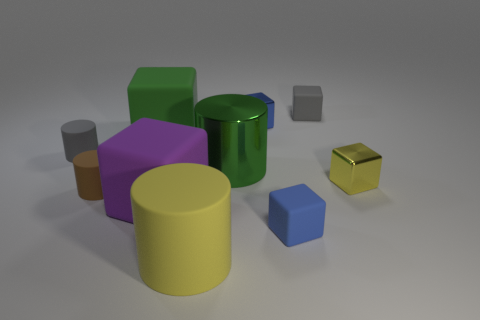Is the number of small gray rubber cylinders that are right of the brown matte cylinder less than the number of rubber blocks that are to the left of the gray matte block?
Ensure brevity in your answer.  Yes. How many large objects are either cylinders or green metal objects?
Give a very brief answer. 2. There is a small gray object to the left of the big yellow rubber cylinder; does it have the same shape as the green metallic object that is behind the tiny yellow metal block?
Ensure brevity in your answer.  Yes. What size is the blue block in front of the tiny matte cylinder that is behind the yellow object that is behind the blue rubber thing?
Ensure brevity in your answer.  Small. There is a green object that is to the left of the large yellow rubber cylinder; how big is it?
Give a very brief answer. Large. There is a tiny blue cube that is in front of the small yellow metal cube; what is its material?
Your answer should be very brief. Rubber. What number of yellow things are either big cylinders or small metal things?
Provide a short and direct response. 2. Are the small gray cylinder and the yellow object that is left of the blue metallic object made of the same material?
Your answer should be compact. Yes. Are there an equal number of tiny yellow objects that are in front of the yellow rubber thing and yellow objects that are behind the big purple object?
Provide a succinct answer. No. Do the yellow block and the blue block that is in front of the small brown rubber cylinder have the same size?
Give a very brief answer. Yes. 